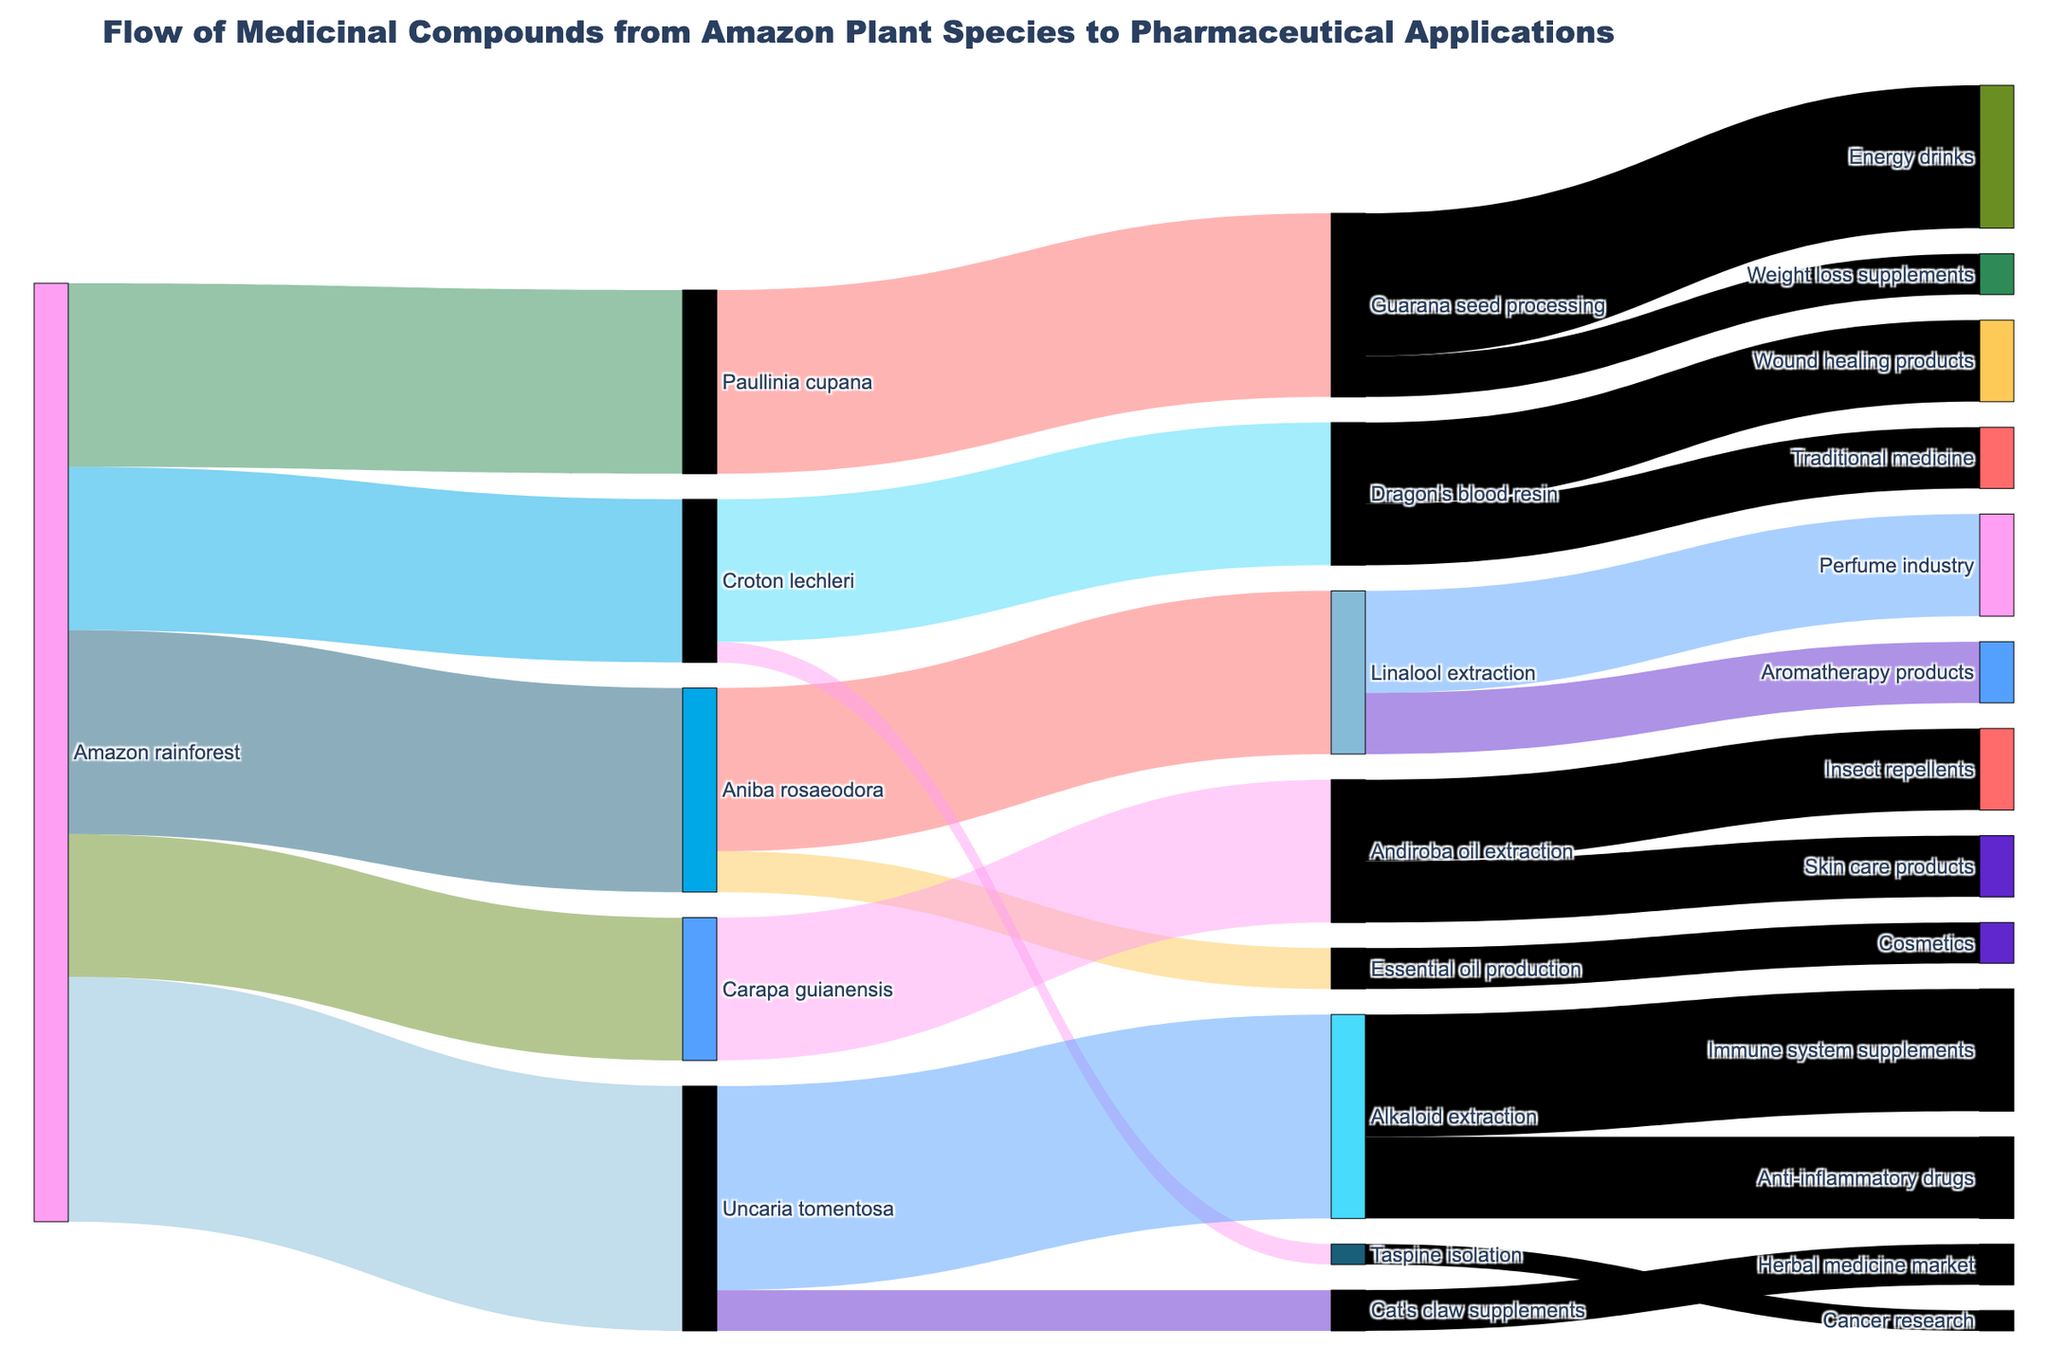Which plant species has the highest value in the initial flow from the Amazon rainforest? Uncaria tomentosa has the highest initial value with 120 units flowing from the Amazon rainforest.
Answer: Uncaria tomentosa How many plant species are sourced from the Amazon rainforest? There are five plant species sourced from the Amazon rainforest: Aniba rosaeodora, Croton lechleri, Uncaria tomentosa, Paullinia cupana, and Carapa guianensis.
Answer: Five What is the total value of medicinal compounds extracted from Aniba rosaeodora? The total value from Aniba rosaeodora is calculated by summing the values of Linalool extraction (80) and Essential oil production (20). This results in 80 + 20 = 100 units.
Answer: 100 Which downstream application receives the largest amount of medicinal compounds from a single type of extraction? The Perfume industry receives 50 units from Linalool extraction, which is the largest amount for a single downstream application.
Answer: Perfume industry Which pharmaceutical application receives medicinal compounds from the most sources? Both the Perfume industry and Energy drinks receive medicinal compounds, but each gets them from only one source. However, 'Perfume industry' and 'Energy drinks' both get medicinal compounds from two paths (via Linalool extraction from Aniba rosaeodora and Guarana seed processing from Paullinia cupana, respectively). These are the maximum.
Answer: Tie (two sources each) What is the sum of values in the entire pharmaceutical application flow starting from the Amazon rainforest? Summing all values: 100 (Aniba rosaeodora) + 80 (Croton lechleri) + 120 (Uncaria tomentosa) + 90 (Paullinia cupana) + 70 (Carapa guianensis) = 100 + 80 + 120 + 90 + 70 = 460 units.
Answer: 460 Which extraction method has the highest flow value, and what is the value it contributes to its respective applications? Alkaloid extraction from Uncaria tomentosa has the highest extracted value contributing a total of 100 units: 60 to Immune system supplements and 40 to Anti-inflammatory drugs.
Answer: Alkaloid extraction, 100 units What is the combined flow value going into the traditional medicine from the plant species? Traditional medicine receives 30 units from Dragon's blood resin which comes from Croton lechleri.
Answer: 30 Compare the flow value of essential oil production from Aniba rosaeodora to the wound healing products from Croton lechleri. Which one is higher and by what value? Essential oil production has 20 units, while wound healing products receive 40 units from Dragon's blood resin. Wound healing products receive 20 units more than essential oil production.
Answer: Wound healing, by 20 units How many pharmaceutical applications receive less than 30 units of medicinal compounds? Four pharmaceutical applications receive less than 30 units: Essential oil production (20), Taspine isolation (10), Traditional medicine (30), and Weight loss supplements (20).
Answer: Four 